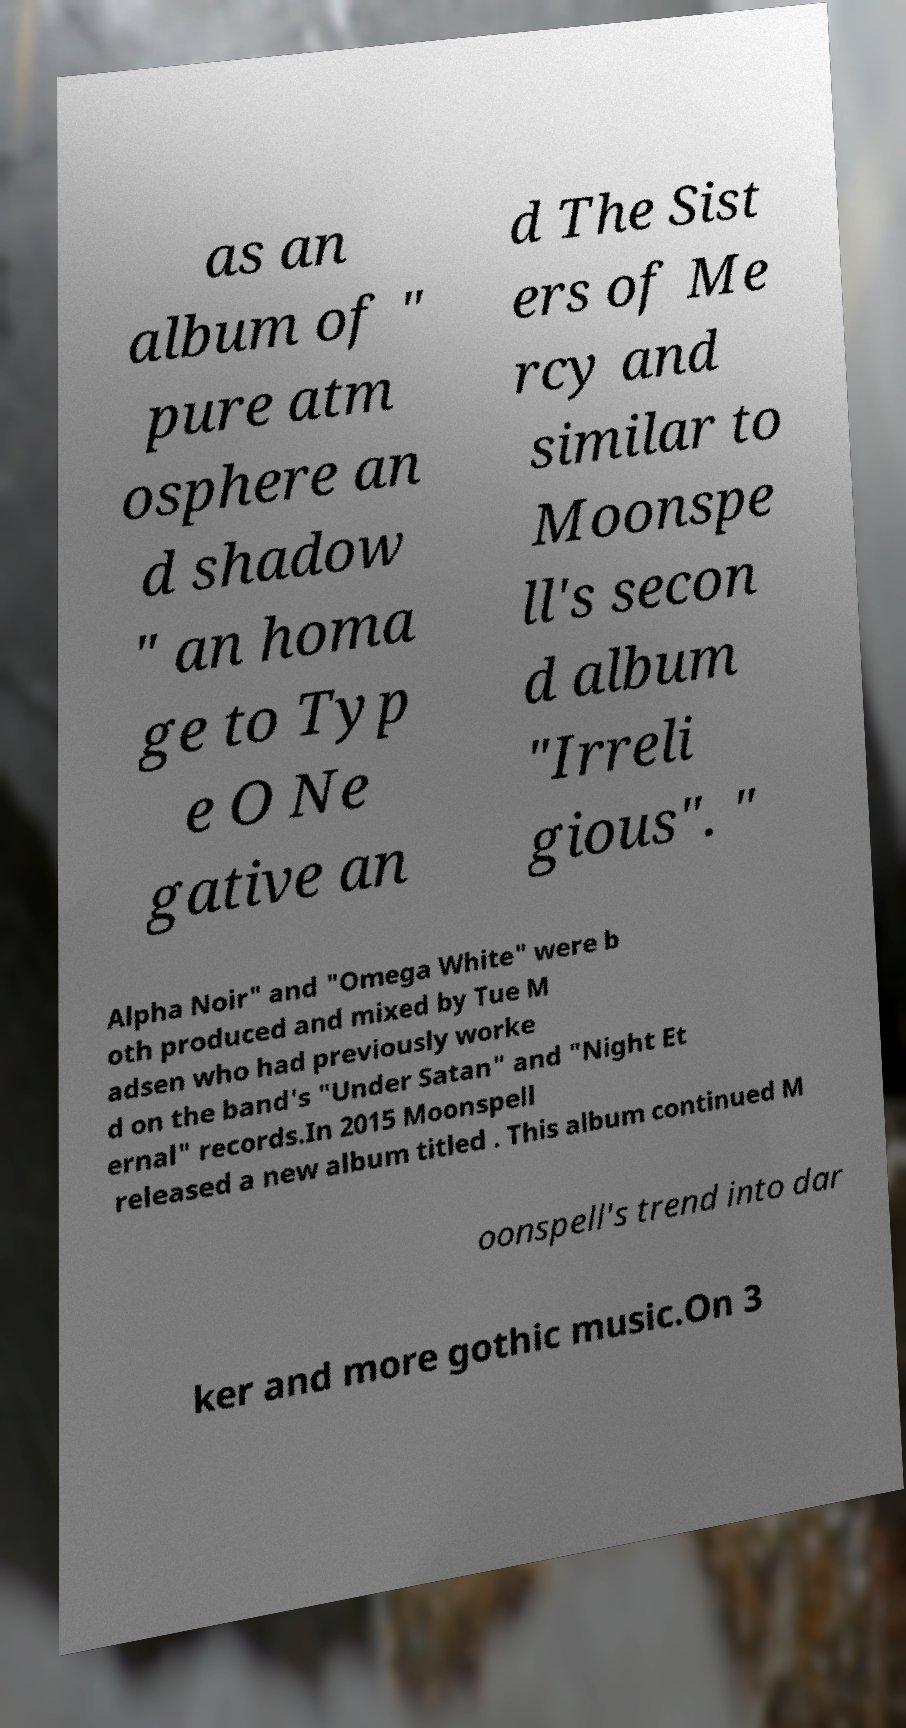I need the written content from this picture converted into text. Can you do that? as an album of " pure atm osphere an d shadow " an homa ge to Typ e O Ne gative an d The Sist ers of Me rcy and similar to Moonspe ll's secon d album "Irreli gious". " Alpha Noir" and "Omega White" were b oth produced and mixed by Tue M adsen who had previously worke d on the band's "Under Satan" and "Night Et ernal" records.In 2015 Moonspell released a new album titled . This album continued M oonspell's trend into dar ker and more gothic music.On 3 